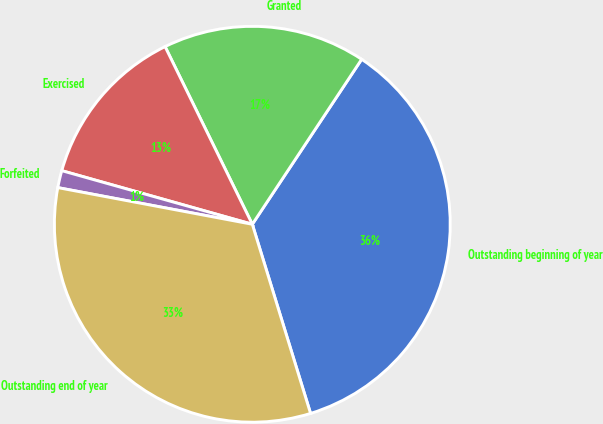<chart> <loc_0><loc_0><loc_500><loc_500><pie_chart><fcel>Outstanding beginning of year<fcel>Granted<fcel>Exercised<fcel>Forfeited<fcel>Outstanding end of year<nl><fcel>35.93%<fcel>16.58%<fcel>13.37%<fcel>1.4%<fcel>32.72%<nl></chart> 